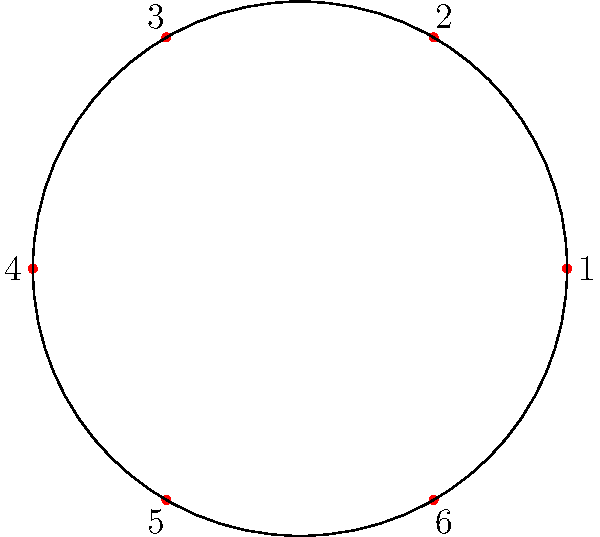In a circular arrangement of Vietnamese dog toys, there are 6 toys labeled from 1 to 6. The rotation of these toys forms a cyclic group of order 6. If we apply the group operation twice, which is equivalent to rotating the toys clockwise by two positions, what is the resulting permutation in cycle notation? Let's approach this step-by-step:

1) First, we need to understand what a single rotation does:
   1 → 6, 2 → 1, 3 → 2, 4 → 3, 5 → 4, 6 → 5
   This can be written in cycle notation as (123456).

2) We are asked to apply this operation twice, which means we rotate by two positions.

3) To find the result, we can either:
   a) Apply the single rotation twice, or
   b) Directly determine where each element ends up after two rotations.

4) Let's use method b:
   1 → 5, 2 → 6, 3 → 1, 4 → 2, 5 → 3, 6 → 4

5) Now, we need to write this as a product of disjoint cycles:
   We start with 1: 1 → 5 → 3 → 1 (cycle closes)
   Next unused number is 2: 2 → 6 → 4 → 2 (cycle closes)

6) Therefore, the permutation in cycle notation is (153)(264).
Answer: $(153)(264)$ 